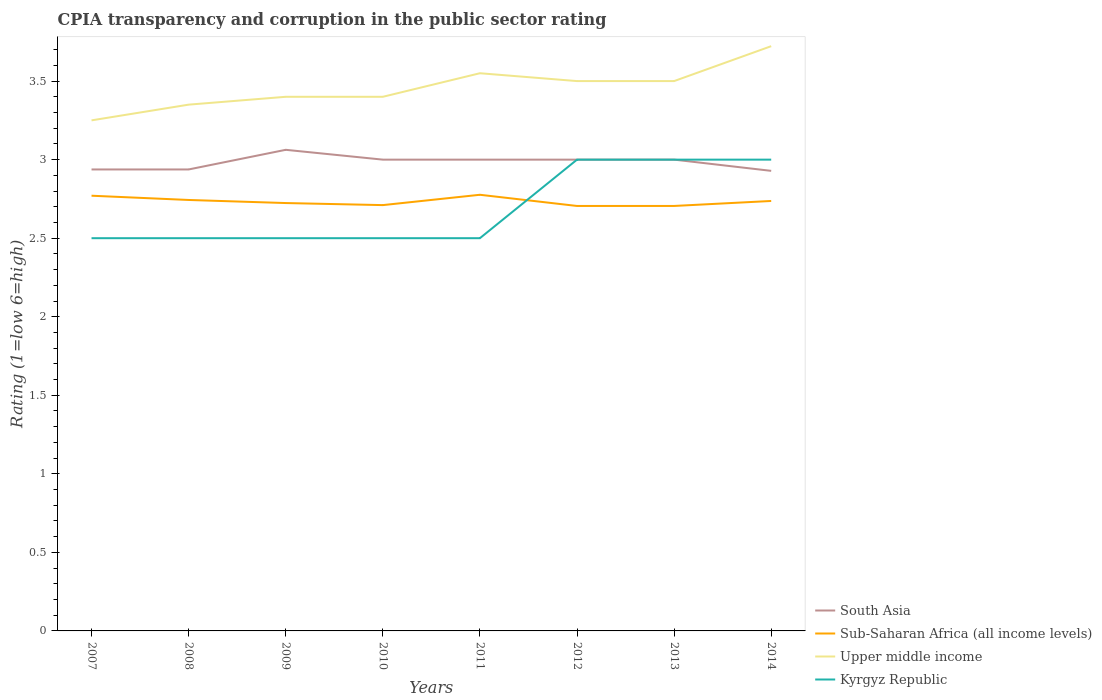Is the number of lines equal to the number of legend labels?
Give a very brief answer. Yes. Across all years, what is the maximum CPIA rating in Sub-Saharan Africa (all income levels)?
Offer a very short reply. 2.71. In which year was the CPIA rating in South Asia maximum?
Make the answer very short. 2014. What is the total CPIA rating in Sub-Saharan Africa (all income levels) in the graph?
Make the answer very short. 0.03. What is the difference between the highest and the second highest CPIA rating in South Asia?
Ensure brevity in your answer.  0.13. What is the difference between the highest and the lowest CPIA rating in Upper middle income?
Give a very brief answer. 4. Is the CPIA rating in Kyrgyz Republic strictly greater than the CPIA rating in Sub-Saharan Africa (all income levels) over the years?
Your response must be concise. No. How many years are there in the graph?
Your answer should be very brief. 8. Are the values on the major ticks of Y-axis written in scientific E-notation?
Keep it short and to the point. No. Does the graph contain grids?
Your answer should be very brief. No. Where does the legend appear in the graph?
Give a very brief answer. Bottom right. How are the legend labels stacked?
Ensure brevity in your answer.  Vertical. What is the title of the graph?
Your answer should be compact. CPIA transparency and corruption in the public sector rating. What is the Rating (1=low 6=high) of South Asia in 2007?
Ensure brevity in your answer.  2.94. What is the Rating (1=low 6=high) of Sub-Saharan Africa (all income levels) in 2007?
Make the answer very short. 2.77. What is the Rating (1=low 6=high) in Kyrgyz Republic in 2007?
Ensure brevity in your answer.  2.5. What is the Rating (1=low 6=high) in South Asia in 2008?
Offer a very short reply. 2.94. What is the Rating (1=low 6=high) in Sub-Saharan Africa (all income levels) in 2008?
Provide a short and direct response. 2.74. What is the Rating (1=low 6=high) in Upper middle income in 2008?
Ensure brevity in your answer.  3.35. What is the Rating (1=low 6=high) in Kyrgyz Republic in 2008?
Offer a very short reply. 2.5. What is the Rating (1=low 6=high) of South Asia in 2009?
Ensure brevity in your answer.  3.06. What is the Rating (1=low 6=high) in Sub-Saharan Africa (all income levels) in 2009?
Offer a very short reply. 2.72. What is the Rating (1=low 6=high) of Upper middle income in 2009?
Your response must be concise. 3.4. What is the Rating (1=low 6=high) in Kyrgyz Republic in 2009?
Ensure brevity in your answer.  2.5. What is the Rating (1=low 6=high) of South Asia in 2010?
Offer a very short reply. 3. What is the Rating (1=low 6=high) in Sub-Saharan Africa (all income levels) in 2010?
Your answer should be very brief. 2.71. What is the Rating (1=low 6=high) of Upper middle income in 2010?
Give a very brief answer. 3.4. What is the Rating (1=low 6=high) in Sub-Saharan Africa (all income levels) in 2011?
Ensure brevity in your answer.  2.78. What is the Rating (1=low 6=high) in Upper middle income in 2011?
Your answer should be compact. 3.55. What is the Rating (1=low 6=high) in South Asia in 2012?
Offer a terse response. 3. What is the Rating (1=low 6=high) in Sub-Saharan Africa (all income levels) in 2012?
Your answer should be very brief. 2.71. What is the Rating (1=low 6=high) of Kyrgyz Republic in 2012?
Offer a terse response. 3. What is the Rating (1=low 6=high) in Sub-Saharan Africa (all income levels) in 2013?
Provide a succinct answer. 2.71. What is the Rating (1=low 6=high) of Upper middle income in 2013?
Offer a terse response. 3.5. What is the Rating (1=low 6=high) of Kyrgyz Republic in 2013?
Provide a short and direct response. 3. What is the Rating (1=low 6=high) in South Asia in 2014?
Offer a terse response. 2.93. What is the Rating (1=low 6=high) in Sub-Saharan Africa (all income levels) in 2014?
Offer a terse response. 2.74. What is the Rating (1=low 6=high) of Upper middle income in 2014?
Your response must be concise. 3.72. Across all years, what is the maximum Rating (1=low 6=high) in South Asia?
Give a very brief answer. 3.06. Across all years, what is the maximum Rating (1=low 6=high) of Sub-Saharan Africa (all income levels)?
Give a very brief answer. 2.78. Across all years, what is the maximum Rating (1=low 6=high) in Upper middle income?
Offer a very short reply. 3.72. Across all years, what is the maximum Rating (1=low 6=high) in Kyrgyz Republic?
Offer a very short reply. 3. Across all years, what is the minimum Rating (1=low 6=high) of South Asia?
Your answer should be very brief. 2.93. Across all years, what is the minimum Rating (1=low 6=high) in Sub-Saharan Africa (all income levels)?
Your answer should be very brief. 2.71. Across all years, what is the minimum Rating (1=low 6=high) in Upper middle income?
Your answer should be compact. 3.25. What is the total Rating (1=low 6=high) of South Asia in the graph?
Give a very brief answer. 23.87. What is the total Rating (1=low 6=high) of Sub-Saharan Africa (all income levels) in the graph?
Your answer should be very brief. 21.87. What is the total Rating (1=low 6=high) of Upper middle income in the graph?
Your response must be concise. 27.67. What is the total Rating (1=low 6=high) of Kyrgyz Republic in the graph?
Give a very brief answer. 21.5. What is the difference between the Rating (1=low 6=high) in South Asia in 2007 and that in 2008?
Make the answer very short. 0. What is the difference between the Rating (1=low 6=high) of Sub-Saharan Africa (all income levels) in 2007 and that in 2008?
Offer a very short reply. 0.03. What is the difference between the Rating (1=low 6=high) in Upper middle income in 2007 and that in 2008?
Provide a succinct answer. -0.1. What is the difference between the Rating (1=low 6=high) of South Asia in 2007 and that in 2009?
Keep it short and to the point. -0.12. What is the difference between the Rating (1=low 6=high) in Sub-Saharan Africa (all income levels) in 2007 and that in 2009?
Ensure brevity in your answer.  0.05. What is the difference between the Rating (1=low 6=high) of Upper middle income in 2007 and that in 2009?
Offer a very short reply. -0.15. What is the difference between the Rating (1=low 6=high) of Kyrgyz Republic in 2007 and that in 2009?
Make the answer very short. 0. What is the difference between the Rating (1=low 6=high) of South Asia in 2007 and that in 2010?
Your answer should be very brief. -0.06. What is the difference between the Rating (1=low 6=high) of Sub-Saharan Africa (all income levels) in 2007 and that in 2010?
Ensure brevity in your answer.  0.06. What is the difference between the Rating (1=low 6=high) of Upper middle income in 2007 and that in 2010?
Make the answer very short. -0.15. What is the difference between the Rating (1=low 6=high) in Kyrgyz Republic in 2007 and that in 2010?
Keep it short and to the point. 0. What is the difference between the Rating (1=low 6=high) in South Asia in 2007 and that in 2011?
Provide a short and direct response. -0.06. What is the difference between the Rating (1=low 6=high) in Sub-Saharan Africa (all income levels) in 2007 and that in 2011?
Your response must be concise. -0.01. What is the difference between the Rating (1=low 6=high) of Kyrgyz Republic in 2007 and that in 2011?
Keep it short and to the point. 0. What is the difference between the Rating (1=low 6=high) in South Asia in 2007 and that in 2012?
Keep it short and to the point. -0.06. What is the difference between the Rating (1=low 6=high) of Sub-Saharan Africa (all income levels) in 2007 and that in 2012?
Give a very brief answer. 0.07. What is the difference between the Rating (1=low 6=high) of Kyrgyz Republic in 2007 and that in 2012?
Provide a short and direct response. -0.5. What is the difference between the Rating (1=low 6=high) of South Asia in 2007 and that in 2013?
Provide a succinct answer. -0.06. What is the difference between the Rating (1=low 6=high) in Sub-Saharan Africa (all income levels) in 2007 and that in 2013?
Offer a terse response. 0.07. What is the difference between the Rating (1=low 6=high) in Kyrgyz Republic in 2007 and that in 2013?
Provide a short and direct response. -0.5. What is the difference between the Rating (1=low 6=high) in South Asia in 2007 and that in 2014?
Provide a succinct answer. 0.01. What is the difference between the Rating (1=low 6=high) in Sub-Saharan Africa (all income levels) in 2007 and that in 2014?
Your answer should be compact. 0.03. What is the difference between the Rating (1=low 6=high) of Upper middle income in 2007 and that in 2014?
Your response must be concise. -0.47. What is the difference between the Rating (1=low 6=high) of South Asia in 2008 and that in 2009?
Your answer should be compact. -0.12. What is the difference between the Rating (1=low 6=high) of Sub-Saharan Africa (all income levels) in 2008 and that in 2009?
Offer a terse response. 0.02. What is the difference between the Rating (1=low 6=high) in Upper middle income in 2008 and that in 2009?
Give a very brief answer. -0.05. What is the difference between the Rating (1=low 6=high) of South Asia in 2008 and that in 2010?
Provide a short and direct response. -0.06. What is the difference between the Rating (1=low 6=high) of Sub-Saharan Africa (all income levels) in 2008 and that in 2010?
Make the answer very short. 0.03. What is the difference between the Rating (1=low 6=high) in Upper middle income in 2008 and that in 2010?
Offer a terse response. -0.05. What is the difference between the Rating (1=low 6=high) in Kyrgyz Republic in 2008 and that in 2010?
Make the answer very short. 0. What is the difference between the Rating (1=low 6=high) of South Asia in 2008 and that in 2011?
Offer a very short reply. -0.06. What is the difference between the Rating (1=low 6=high) in Sub-Saharan Africa (all income levels) in 2008 and that in 2011?
Provide a succinct answer. -0.03. What is the difference between the Rating (1=low 6=high) of South Asia in 2008 and that in 2012?
Offer a very short reply. -0.06. What is the difference between the Rating (1=low 6=high) of Sub-Saharan Africa (all income levels) in 2008 and that in 2012?
Keep it short and to the point. 0.04. What is the difference between the Rating (1=low 6=high) of Upper middle income in 2008 and that in 2012?
Your answer should be very brief. -0.15. What is the difference between the Rating (1=low 6=high) of Kyrgyz Republic in 2008 and that in 2012?
Offer a terse response. -0.5. What is the difference between the Rating (1=low 6=high) in South Asia in 2008 and that in 2013?
Offer a very short reply. -0.06. What is the difference between the Rating (1=low 6=high) in Sub-Saharan Africa (all income levels) in 2008 and that in 2013?
Your response must be concise. 0.04. What is the difference between the Rating (1=low 6=high) of Upper middle income in 2008 and that in 2013?
Provide a short and direct response. -0.15. What is the difference between the Rating (1=low 6=high) in South Asia in 2008 and that in 2014?
Your answer should be very brief. 0.01. What is the difference between the Rating (1=low 6=high) of Sub-Saharan Africa (all income levels) in 2008 and that in 2014?
Offer a terse response. 0.01. What is the difference between the Rating (1=low 6=high) in Upper middle income in 2008 and that in 2014?
Your answer should be very brief. -0.37. What is the difference between the Rating (1=low 6=high) of South Asia in 2009 and that in 2010?
Give a very brief answer. 0.06. What is the difference between the Rating (1=low 6=high) in Sub-Saharan Africa (all income levels) in 2009 and that in 2010?
Make the answer very short. 0.01. What is the difference between the Rating (1=low 6=high) of South Asia in 2009 and that in 2011?
Make the answer very short. 0.06. What is the difference between the Rating (1=low 6=high) of Sub-Saharan Africa (all income levels) in 2009 and that in 2011?
Offer a terse response. -0.05. What is the difference between the Rating (1=low 6=high) of Upper middle income in 2009 and that in 2011?
Provide a short and direct response. -0.15. What is the difference between the Rating (1=low 6=high) of Kyrgyz Republic in 2009 and that in 2011?
Provide a succinct answer. 0. What is the difference between the Rating (1=low 6=high) of South Asia in 2009 and that in 2012?
Provide a succinct answer. 0.06. What is the difference between the Rating (1=low 6=high) of Sub-Saharan Africa (all income levels) in 2009 and that in 2012?
Provide a short and direct response. 0.02. What is the difference between the Rating (1=low 6=high) of Upper middle income in 2009 and that in 2012?
Make the answer very short. -0.1. What is the difference between the Rating (1=low 6=high) of Kyrgyz Republic in 2009 and that in 2012?
Provide a short and direct response. -0.5. What is the difference between the Rating (1=low 6=high) of South Asia in 2009 and that in 2013?
Offer a very short reply. 0.06. What is the difference between the Rating (1=low 6=high) of Sub-Saharan Africa (all income levels) in 2009 and that in 2013?
Make the answer very short. 0.02. What is the difference between the Rating (1=low 6=high) of South Asia in 2009 and that in 2014?
Your answer should be compact. 0.13. What is the difference between the Rating (1=low 6=high) in Sub-Saharan Africa (all income levels) in 2009 and that in 2014?
Your answer should be compact. -0.01. What is the difference between the Rating (1=low 6=high) of Upper middle income in 2009 and that in 2014?
Keep it short and to the point. -0.32. What is the difference between the Rating (1=low 6=high) in Kyrgyz Republic in 2009 and that in 2014?
Keep it short and to the point. -0.5. What is the difference between the Rating (1=low 6=high) of Sub-Saharan Africa (all income levels) in 2010 and that in 2011?
Your answer should be very brief. -0.07. What is the difference between the Rating (1=low 6=high) in Upper middle income in 2010 and that in 2011?
Your answer should be very brief. -0.15. What is the difference between the Rating (1=low 6=high) of Kyrgyz Republic in 2010 and that in 2011?
Provide a succinct answer. 0. What is the difference between the Rating (1=low 6=high) in Sub-Saharan Africa (all income levels) in 2010 and that in 2012?
Your response must be concise. 0.01. What is the difference between the Rating (1=low 6=high) of Kyrgyz Republic in 2010 and that in 2012?
Your answer should be very brief. -0.5. What is the difference between the Rating (1=low 6=high) of South Asia in 2010 and that in 2013?
Your answer should be very brief. 0. What is the difference between the Rating (1=low 6=high) in Sub-Saharan Africa (all income levels) in 2010 and that in 2013?
Your response must be concise. 0.01. What is the difference between the Rating (1=low 6=high) of Upper middle income in 2010 and that in 2013?
Give a very brief answer. -0.1. What is the difference between the Rating (1=low 6=high) of South Asia in 2010 and that in 2014?
Provide a short and direct response. 0.07. What is the difference between the Rating (1=low 6=high) of Sub-Saharan Africa (all income levels) in 2010 and that in 2014?
Offer a very short reply. -0.03. What is the difference between the Rating (1=low 6=high) of Upper middle income in 2010 and that in 2014?
Provide a short and direct response. -0.32. What is the difference between the Rating (1=low 6=high) in Sub-Saharan Africa (all income levels) in 2011 and that in 2012?
Offer a very short reply. 0.07. What is the difference between the Rating (1=low 6=high) of Sub-Saharan Africa (all income levels) in 2011 and that in 2013?
Your response must be concise. 0.07. What is the difference between the Rating (1=low 6=high) of Upper middle income in 2011 and that in 2013?
Your response must be concise. 0.05. What is the difference between the Rating (1=low 6=high) in South Asia in 2011 and that in 2014?
Give a very brief answer. 0.07. What is the difference between the Rating (1=low 6=high) of Sub-Saharan Africa (all income levels) in 2011 and that in 2014?
Provide a succinct answer. 0.04. What is the difference between the Rating (1=low 6=high) of Upper middle income in 2011 and that in 2014?
Make the answer very short. -0.17. What is the difference between the Rating (1=low 6=high) in Sub-Saharan Africa (all income levels) in 2012 and that in 2013?
Offer a terse response. 0. What is the difference between the Rating (1=low 6=high) in Kyrgyz Republic in 2012 and that in 2013?
Give a very brief answer. 0. What is the difference between the Rating (1=low 6=high) of South Asia in 2012 and that in 2014?
Your answer should be very brief. 0.07. What is the difference between the Rating (1=low 6=high) of Sub-Saharan Africa (all income levels) in 2012 and that in 2014?
Keep it short and to the point. -0.03. What is the difference between the Rating (1=low 6=high) in Upper middle income in 2012 and that in 2014?
Provide a short and direct response. -0.22. What is the difference between the Rating (1=low 6=high) of Kyrgyz Republic in 2012 and that in 2014?
Give a very brief answer. 0. What is the difference between the Rating (1=low 6=high) in South Asia in 2013 and that in 2014?
Your response must be concise. 0.07. What is the difference between the Rating (1=low 6=high) of Sub-Saharan Africa (all income levels) in 2013 and that in 2014?
Offer a very short reply. -0.03. What is the difference between the Rating (1=low 6=high) of Upper middle income in 2013 and that in 2014?
Make the answer very short. -0.22. What is the difference between the Rating (1=low 6=high) in Kyrgyz Republic in 2013 and that in 2014?
Ensure brevity in your answer.  0. What is the difference between the Rating (1=low 6=high) of South Asia in 2007 and the Rating (1=low 6=high) of Sub-Saharan Africa (all income levels) in 2008?
Provide a succinct answer. 0.19. What is the difference between the Rating (1=low 6=high) in South Asia in 2007 and the Rating (1=low 6=high) in Upper middle income in 2008?
Provide a succinct answer. -0.41. What is the difference between the Rating (1=low 6=high) in South Asia in 2007 and the Rating (1=low 6=high) in Kyrgyz Republic in 2008?
Your answer should be compact. 0.44. What is the difference between the Rating (1=low 6=high) of Sub-Saharan Africa (all income levels) in 2007 and the Rating (1=low 6=high) of Upper middle income in 2008?
Ensure brevity in your answer.  -0.58. What is the difference between the Rating (1=low 6=high) of Sub-Saharan Africa (all income levels) in 2007 and the Rating (1=low 6=high) of Kyrgyz Republic in 2008?
Your answer should be very brief. 0.27. What is the difference between the Rating (1=low 6=high) in Upper middle income in 2007 and the Rating (1=low 6=high) in Kyrgyz Republic in 2008?
Ensure brevity in your answer.  0.75. What is the difference between the Rating (1=low 6=high) of South Asia in 2007 and the Rating (1=low 6=high) of Sub-Saharan Africa (all income levels) in 2009?
Your answer should be very brief. 0.21. What is the difference between the Rating (1=low 6=high) of South Asia in 2007 and the Rating (1=low 6=high) of Upper middle income in 2009?
Your answer should be compact. -0.46. What is the difference between the Rating (1=low 6=high) of South Asia in 2007 and the Rating (1=low 6=high) of Kyrgyz Republic in 2009?
Your answer should be compact. 0.44. What is the difference between the Rating (1=low 6=high) in Sub-Saharan Africa (all income levels) in 2007 and the Rating (1=low 6=high) in Upper middle income in 2009?
Offer a very short reply. -0.63. What is the difference between the Rating (1=low 6=high) of Sub-Saharan Africa (all income levels) in 2007 and the Rating (1=low 6=high) of Kyrgyz Republic in 2009?
Keep it short and to the point. 0.27. What is the difference between the Rating (1=low 6=high) in Upper middle income in 2007 and the Rating (1=low 6=high) in Kyrgyz Republic in 2009?
Your answer should be compact. 0.75. What is the difference between the Rating (1=low 6=high) in South Asia in 2007 and the Rating (1=low 6=high) in Sub-Saharan Africa (all income levels) in 2010?
Offer a very short reply. 0.23. What is the difference between the Rating (1=low 6=high) of South Asia in 2007 and the Rating (1=low 6=high) of Upper middle income in 2010?
Give a very brief answer. -0.46. What is the difference between the Rating (1=low 6=high) of South Asia in 2007 and the Rating (1=low 6=high) of Kyrgyz Republic in 2010?
Provide a succinct answer. 0.44. What is the difference between the Rating (1=low 6=high) of Sub-Saharan Africa (all income levels) in 2007 and the Rating (1=low 6=high) of Upper middle income in 2010?
Make the answer very short. -0.63. What is the difference between the Rating (1=low 6=high) in Sub-Saharan Africa (all income levels) in 2007 and the Rating (1=low 6=high) in Kyrgyz Republic in 2010?
Offer a terse response. 0.27. What is the difference between the Rating (1=low 6=high) of Upper middle income in 2007 and the Rating (1=low 6=high) of Kyrgyz Republic in 2010?
Make the answer very short. 0.75. What is the difference between the Rating (1=low 6=high) in South Asia in 2007 and the Rating (1=low 6=high) in Sub-Saharan Africa (all income levels) in 2011?
Give a very brief answer. 0.16. What is the difference between the Rating (1=low 6=high) in South Asia in 2007 and the Rating (1=low 6=high) in Upper middle income in 2011?
Make the answer very short. -0.61. What is the difference between the Rating (1=low 6=high) in South Asia in 2007 and the Rating (1=low 6=high) in Kyrgyz Republic in 2011?
Ensure brevity in your answer.  0.44. What is the difference between the Rating (1=low 6=high) of Sub-Saharan Africa (all income levels) in 2007 and the Rating (1=low 6=high) of Upper middle income in 2011?
Ensure brevity in your answer.  -0.78. What is the difference between the Rating (1=low 6=high) in Sub-Saharan Africa (all income levels) in 2007 and the Rating (1=low 6=high) in Kyrgyz Republic in 2011?
Provide a short and direct response. 0.27. What is the difference between the Rating (1=low 6=high) in Upper middle income in 2007 and the Rating (1=low 6=high) in Kyrgyz Republic in 2011?
Your answer should be very brief. 0.75. What is the difference between the Rating (1=low 6=high) of South Asia in 2007 and the Rating (1=low 6=high) of Sub-Saharan Africa (all income levels) in 2012?
Your answer should be very brief. 0.23. What is the difference between the Rating (1=low 6=high) in South Asia in 2007 and the Rating (1=low 6=high) in Upper middle income in 2012?
Keep it short and to the point. -0.56. What is the difference between the Rating (1=low 6=high) of South Asia in 2007 and the Rating (1=low 6=high) of Kyrgyz Republic in 2012?
Ensure brevity in your answer.  -0.06. What is the difference between the Rating (1=low 6=high) in Sub-Saharan Africa (all income levels) in 2007 and the Rating (1=low 6=high) in Upper middle income in 2012?
Keep it short and to the point. -0.73. What is the difference between the Rating (1=low 6=high) of Sub-Saharan Africa (all income levels) in 2007 and the Rating (1=low 6=high) of Kyrgyz Republic in 2012?
Your answer should be compact. -0.23. What is the difference between the Rating (1=low 6=high) in South Asia in 2007 and the Rating (1=low 6=high) in Sub-Saharan Africa (all income levels) in 2013?
Keep it short and to the point. 0.23. What is the difference between the Rating (1=low 6=high) of South Asia in 2007 and the Rating (1=low 6=high) of Upper middle income in 2013?
Provide a short and direct response. -0.56. What is the difference between the Rating (1=low 6=high) of South Asia in 2007 and the Rating (1=low 6=high) of Kyrgyz Republic in 2013?
Offer a terse response. -0.06. What is the difference between the Rating (1=low 6=high) of Sub-Saharan Africa (all income levels) in 2007 and the Rating (1=low 6=high) of Upper middle income in 2013?
Provide a short and direct response. -0.73. What is the difference between the Rating (1=low 6=high) in Sub-Saharan Africa (all income levels) in 2007 and the Rating (1=low 6=high) in Kyrgyz Republic in 2013?
Give a very brief answer. -0.23. What is the difference between the Rating (1=low 6=high) in South Asia in 2007 and the Rating (1=low 6=high) in Sub-Saharan Africa (all income levels) in 2014?
Offer a very short reply. 0.2. What is the difference between the Rating (1=low 6=high) in South Asia in 2007 and the Rating (1=low 6=high) in Upper middle income in 2014?
Ensure brevity in your answer.  -0.78. What is the difference between the Rating (1=low 6=high) of South Asia in 2007 and the Rating (1=low 6=high) of Kyrgyz Republic in 2014?
Give a very brief answer. -0.06. What is the difference between the Rating (1=low 6=high) in Sub-Saharan Africa (all income levels) in 2007 and the Rating (1=low 6=high) in Upper middle income in 2014?
Offer a terse response. -0.95. What is the difference between the Rating (1=low 6=high) in Sub-Saharan Africa (all income levels) in 2007 and the Rating (1=low 6=high) in Kyrgyz Republic in 2014?
Your response must be concise. -0.23. What is the difference between the Rating (1=low 6=high) in South Asia in 2008 and the Rating (1=low 6=high) in Sub-Saharan Africa (all income levels) in 2009?
Your answer should be compact. 0.21. What is the difference between the Rating (1=low 6=high) of South Asia in 2008 and the Rating (1=low 6=high) of Upper middle income in 2009?
Your answer should be compact. -0.46. What is the difference between the Rating (1=low 6=high) of South Asia in 2008 and the Rating (1=low 6=high) of Kyrgyz Republic in 2009?
Keep it short and to the point. 0.44. What is the difference between the Rating (1=low 6=high) of Sub-Saharan Africa (all income levels) in 2008 and the Rating (1=low 6=high) of Upper middle income in 2009?
Your answer should be very brief. -0.66. What is the difference between the Rating (1=low 6=high) in Sub-Saharan Africa (all income levels) in 2008 and the Rating (1=low 6=high) in Kyrgyz Republic in 2009?
Give a very brief answer. 0.24. What is the difference between the Rating (1=low 6=high) in South Asia in 2008 and the Rating (1=low 6=high) in Sub-Saharan Africa (all income levels) in 2010?
Provide a succinct answer. 0.23. What is the difference between the Rating (1=low 6=high) in South Asia in 2008 and the Rating (1=low 6=high) in Upper middle income in 2010?
Your answer should be very brief. -0.46. What is the difference between the Rating (1=low 6=high) of South Asia in 2008 and the Rating (1=low 6=high) of Kyrgyz Republic in 2010?
Provide a short and direct response. 0.44. What is the difference between the Rating (1=low 6=high) in Sub-Saharan Africa (all income levels) in 2008 and the Rating (1=low 6=high) in Upper middle income in 2010?
Your answer should be compact. -0.66. What is the difference between the Rating (1=low 6=high) of Sub-Saharan Africa (all income levels) in 2008 and the Rating (1=low 6=high) of Kyrgyz Republic in 2010?
Make the answer very short. 0.24. What is the difference between the Rating (1=low 6=high) in Upper middle income in 2008 and the Rating (1=low 6=high) in Kyrgyz Republic in 2010?
Keep it short and to the point. 0.85. What is the difference between the Rating (1=low 6=high) in South Asia in 2008 and the Rating (1=low 6=high) in Sub-Saharan Africa (all income levels) in 2011?
Provide a short and direct response. 0.16. What is the difference between the Rating (1=low 6=high) in South Asia in 2008 and the Rating (1=low 6=high) in Upper middle income in 2011?
Keep it short and to the point. -0.61. What is the difference between the Rating (1=low 6=high) in South Asia in 2008 and the Rating (1=low 6=high) in Kyrgyz Republic in 2011?
Your answer should be very brief. 0.44. What is the difference between the Rating (1=low 6=high) in Sub-Saharan Africa (all income levels) in 2008 and the Rating (1=low 6=high) in Upper middle income in 2011?
Your answer should be compact. -0.81. What is the difference between the Rating (1=low 6=high) of Sub-Saharan Africa (all income levels) in 2008 and the Rating (1=low 6=high) of Kyrgyz Republic in 2011?
Give a very brief answer. 0.24. What is the difference between the Rating (1=low 6=high) of South Asia in 2008 and the Rating (1=low 6=high) of Sub-Saharan Africa (all income levels) in 2012?
Make the answer very short. 0.23. What is the difference between the Rating (1=low 6=high) of South Asia in 2008 and the Rating (1=low 6=high) of Upper middle income in 2012?
Your answer should be compact. -0.56. What is the difference between the Rating (1=low 6=high) of South Asia in 2008 and the Rating (1=low 6=high) of Kyrgyz Republic in 2012?
Your response must be concise. -0.06. What is the difference between the Rating (1=low 6=high) in Sub-Saharan Africa (all income levels) in 2008 and the Rating (1=low 6=high) in Upper middle income in 2012?
Offer a terse response. -0.76. What is the difference between the Rating (1=low 6=high) of Sub-Saharan Africa (all income levels) in 2008 and the Rating (1=low 6=high) of Kyrgyz Republic in 2012?
Ensure brevity in your answer.  -0.26. What is the difference between the Rating (1=low 6=high) in Upper middle income in 2008 and the Rating (1=low 6=high) in Kyrgyz Republic in 2012?
Your answer should be compact. 0.35. What is the difference between the Rating (1=low 6=high) in South Asia in 2008 and the Rating (1=low 6=high) in Sub-Saharan Africa (all income levels) in 2013?
Give a very brief answer. 0.23. What is the difference between the Rating (1=low 6=high) of South Asia in 2008 and the Rating (1=low 6=high) of Upper middle income in 2013?
Give a very brief answer. -0.56. What is the difference between the Rating (1=low 6=high) in South Asia in 2008 and the Rating (1=low 6=high) in Kyrgyz Republic in 2013?
Provide a succinct answer. -0.06. What is the difference between the Rating (1=low 6=high) of Sub-Saharan Africa (all income levels) in 2008 and the Rating (1=low 6=high) of Upper middle income in 2013?
Keep it short and to the point. -0.76. What is the difference between the Rating (1=low 6=high) of Sub-Saharan Africa (all income levels) in 2008 and the Rating (1=low 6=high) of Kyrgyz Republic in 2013?
Keep it short and to the point. -0.26. What is the difference between the Rating (1=low 6=high) in South Asia in 2008 and the Rating (1=low 6=high) in Sub-Saharan Africa (all income levels) in 2014?
Provide a succinct answer. 0.2. What is the difference between the Rating (1=low 6=high) of South Asia in 2008 and the Rating (1=low 6=high) of Upper middle income in 2014?
Give a very brief answer. -0.78. What is the difference between the Rating (1=low 6=high) in South Asia in 2008 and the Rating (1=low 6=high) in Kyrgyz Republic in 2014?
Your answer should be very brief. -0.06. What is the difference between the Rating (1=low 6=high) of Sub-Saharan Africa (all income levels) in 2008 and the Rating (1=low 6=high) of Upper middle income in 2014?
Offer a terse response. -0.98. What is the difference between the Rating (1=low 6=high) of Sub-Saharan Africa (all income levels) in 2008 and the Rating (1=low 6=high) of Kyrgyz Republic in 2014?
Provide a succinct answer. -0.26. What is the difference between the Rating (1=low 6=high) in South Asia in 2009 and the Rating (1=low 6=high) in Sub-Saharan Africa (all income levels) in 2010?
Your answer should be compact. 0.35. What is the difference between the Rating (1=low 6=high) in South Asia in 2009 and the Rating (1=low 6=high) in Upper middle income in 2010?
Your response must be concise. -0.34. What is the difference between the Rating (1=low 6=high) in South Asia in 2009 and the Rating (1=low 6=high) in Kyrgyz Republic in 2010?
Give a very brief answer. 0.56. What is the difference between the Rating (1=low 6=high) in Sub-Saharan Africa (all income levels) in 2009 and the Rating (1=low 6=high) in Upper middle income in 2010?
Keep it short and to the point. -0.68. What is the difference between the Rating (1=low 6=high) of Sub-Saharan Africa (all income levels) in 2009 and the Rating (1=low 6=high) of Kyrgyz Republic in 2010?
Give a very brief answer. 0.22. What is the difference between the Rating (1=low 6=high) of South Asia in 2009 and the Rating (1=low 6=high) of Sub-Saharan Africa (all income levels) in 2011?
Provide a short and direct response. 0.29. What is the difference between the Rating (1=low 6=high) of South Asia in 2009 and the Rating (1=low 6=high) of Upper middle income in 2011?
Make the answer very short. -0.49. What is the difference between the Rating (1=low 6=high) in South Asia in 2009 and the Rating (1=low 6=high) in Kyrgyz Republic in 2011?
Provide a succinct answer. 0.56. What is the difference between the Rating (1=low 6=high) in Sub-Saharan Africa (all income levels) in 2009 and the Rating (1=low 6=high) in Upper middle income in 2011?
Provide a succinct answer. -0.83. What is the difference between the Rating (1=low 6=high) in Sub-Saharan Africa (all income levels) in 2009 and the Rating (1=low 6=high) in Kyrgyz Republic in 2011?
Offer a very short reply. 0.22. What is the difference between the Rating (1=low 6=high) of South Asia in 2009 and the Rating (1=low 6=high) of Sub-Saharan Africa (all income levels) in 2012?
Keep it short and to the point. 0.36. What is the difference between the Rating (1=low 6=high) in South Asia in 2009 and the Rating (1=low 6=high) in Upper middle income in 2012?
Your answer should be compact. -0.44. What is the difference between the Rating (1=low 6=high) in South Asia in 2009 and the Rating (1=low 6=high) in Kyrgyz Republic in 2012?
Give a very brief answer. 0.06. What is the difference between the Rating (1=low 6=high) in Sub-Saharan Africa (all income levels) in 2009 and the Rating (1=low 6=high) in Upper middle income in 2012?
Your answer should be compact. -0.78. What is the difference between the Rating (1=low 6=high) of Sub-Saharan Africa (all income levels) in 2009 and the Rating (1=low 6=high) of Kyrgyz Republic in 2012?
Provide a short and direct response. -0.28. What is the difference between the Rating (1=low 6=high) of Upper middle income in 2009 and the Rating (1=low 6=high) of Kyrgyz Republic in 2012?
Your answer should be very brief. 0.4. What is the difference between the Rating (1=low 6=high) in South Asia in 2009 and the Rating (1=low 6=high) in Sub-Saharan Africa (all income levels) in 2013?
Offer a very short reply. 0.36. What is the difference between the Rating (1=low 6=high) of South Asia in 2009 and the Rating (1=low 6=high) of Upper middle income in 2013?
Ensure brevity in your answer.  -0.44. What is the difference between the Rating (1=low 6=high) in South Asia in 2009 and the Rating (1=low 6=high) in Kyrgyz Republic in 2013?
Offer a terse response. 0.06. What is the difference between the Rating (1=low 6=high) of Sub-Saharan Africa (all income levels) in 2009 and the Rating (1=low 6=high) of Upper middle income in 2013?
Offer a terse response. -0.78. What is the difference between the Rating (1=low 6=high) of Sub-Saharan Africa (all income levels) in 2009 and the Rating (1=low 6=high) of Kyrgyz Republic in 2013?
Keep it short and to the point. -0.28. What is the difference between the Rating (1=low 6=high) of Upper middle income in 2009 and the Rating (1=low 6=high) of Kyrgyz Republic in 2013?
Offer a very short reply. 0.4. What is the difference between the Rating (1=low 6=high) in South Asia in 2009 and the Rating (1=low 6=high) in Sub-Saharan Africa (all income levels) in 2014?
Your answer should be compact. 0.33. What is the difference between the Rating (1=low 6=high) of South Asia in 2009 and the Rating (1=low 6=high) of Upper middle income in 2014?
Keep it short and to the point. -0.66. What is the difference between the Rating (1=low 6=high) of South Asia in 2009 and the Rating (1=low 6=high) of Kyrgyz Republic in 2014?
Your answer should be very brief. 0.06. What is the difference between the Rating (1=low 6=high) in Sub-Saharan Africa (all income levels) in 2009 and the Rating (1=low 6=high) in Upper middle income in 2014?
Offer a very short reply. -1. What is the difference between the Rating (1=low 6=high) in Sub-Saharan Africa (all income levels) in 2009 and the Rating (1=low 6=high) in Kyrgyz Republic in 2014?
Offer a very short reply. -0.28. What is the difference between the Rating (1=low 6=high) of South Asia in 2010 and the Rating (1=low 6=high) of Sub-Saharan Africa (all income levels) in 2011?
Keep it short and to the point. 0.22. What is the difference between the Rating (1=low 6=high) in South Asia in 2010 and the Rating (1=low 6=high) in Upper middle income in 2011?
Your response must be concise. -0.55. What is the difference between the Rating (1=low 6=high) in Sub-Saharan Africa (all income levels) in 2010 and the Rating (1=low 6=high) in Upper middle income in 2011?
Give a very brief answer. -0.84. What is the difference between the Rating (1=low 6=high) of Sub-Saharan Africa (all income levels) in 2010 and the Rating (1=low 6=high) of Kyrgyz Republic in 2011?
Your answer should be compact. 0.21. What is the difference between the Rating (1=low 6=high) of South Asia in 2010 and the Rating (1=low 6=high) of Sub-Saharan Africa (all income levels) in 2012?
Offer a terse response. 0.29. What is the difference between the Rating (1=low 6=high) in Sub-Saharan Africa (all income levels) in 2010 and the Rating (1=low 6=high) in Upper middle income in 2012?
Your response must be concise. -0.79. What is the difference between the Rating (1=low 6=high) of Sub-Saharan Africa (all income levels) in 2010 and the Rating (1=low 6=high) of Kyrgyz Republic in 2012?
Provide a succinct answer. -0.29. What is the difference between the Rating (1=low 6=high) of South Asia in 2010 and the Rating (1=low 6=high) of Sub-Saharan Africa (all income levels) in 2013?
Give a very brief answer. 0.29. What is the difference between the Rating (1=low 6=high) in South Asia in 2010 and the Rating (1=low 6=high) in Upper middle income in 2013?
Give a very brief answer. -0.5. What is the difference between the Rating (1=low 6=high) in South Asia in 2010 and the Rating (1=low 6=high) in Kyrgyz Republic in 2013?
Give a very brief answer. 0. What is the difference between the Rating (1=low 6=high) of Sub-Saharan Africa (all income levels) in 2010 and the Rating (1=low 6=high) of Upper middle income in 2013?
Give a very brief answer. -0.79. What is the difference between the Rating (1=low 6=high) in Sub-Saharan Africa (all income levels) in 2010 and the Rating (1=low 6=high) in Kyrgyz Republic in 2013?
Provide a succinct answer. -0.29. What is the difference between the Rating (1=low 6=high) in South Asia in 2010 and the Rating (1=low 6=high) in Sub-Saharan Africa (all income levels) in 2014?
Make the answer very short. 0.26. What is the difference between the Rating (1=low 6=high) in South Asia in 2010 and the Rating (1=low 6=high) in Upper middle income in 2014?
Offer a terse response. -0.72. What is the difference between the Rating (1=low 6=high) in Sub-Saharan Africa (all income levels) in 2010 and the Rating (1=low 6=high) in Upper middle income in 2014?
Your response must be concise. -1.01. What is the difference between the Rating (1=low 6=high) of Sub-Saharan Africa (all income levels) in 2010 and the Rating (1=low 6=high) of Kyrgyz Republic in 2014?
Keep it short and to the point. -0.29. What is the difference between the Rating (1=low 6=high) in South Asia in 2011 and the Rating (1=low 6=high) in Sub-Saharan Africa (all income levels) in 2012?
Ensure brevity in your answer.  0.29. What is the difference between the Rating (1=low 6=high) of South Asia in 2011 and the Rating (1=low 6=high) of Kyrgyz Republic in 2012?
Provide a succinct answer. 0. What is the difference between the Rating (1=low 6=high) in Sub-Saharan Africa (all income levels) in 2011 and the Rating (1=low 6=high) in Upper middle income in 2012?
Ensure brevity in your answer.  -0.72. What is the difference between the Rating (1=low 6=high) in Sub-Saharan Africa (all income levels) in 2011 and the Rating (1=low 6=high) in Kyrgyz Republic in 2012?
Give a very brief answer. -0.22. What is the difference between the Rating (1=low 6=high) of Upper middle income in 2011 and the Rating (1=low 6=high) of Kyrgyz Republic in 2012?
Ensure brevity in your answer.  0.55. What is the difference between the Rating (1=low 6=high) in South Asia in 2011 and the Rating (1=low 6=high) in Sub-Saharan Africa (all income levels) in 2013?
Your answer should be compact. 0.29. What is the difference between the Rating (1=low 6=high) of South Asia in 2011 and the Rating (1=low 6=high) of Upper middle income in 2013?
Make the answer very short. -0.5. What is the difference between the Rating (1=low 6=high) of South Asia in 2011 and the Rating (1=low 6=high) of Kyrgyz Republic in 2013?
Offer a very short reply. 0. What is the difference between the Rating (1=low 6=high) of Sub-Saharan Africa (all income levels) in 2011 and the Rating (1=low 6=high) of Upper middle income in 2013?
Give a very brief answer. -0.72. What is the difference between the Rating (1=low 6=high) of Sub-Saharan Africa (all income levels) in 2011 and the Rating (1=low 6=high) of Kyrgyz Republic in 2013?
Make the answer very short. -0.22. What is the difference between the Rating (1=low 6=high) in Upper middle income in 2011 and the Rating (1=low 6=high) in Kyrgyz Republic in 2013?
Provide a succinct answer. 0.55. What is the difference between the Rating (1=low 6=high) in South Asia in 2011 and the Rating (1=low 6=high) in Sub-Saharan Africa (all income levels) in 2014?
Provide a succinct answer. 0.26. What is the difference between the Rating (1=low 6=high) of South Asia in 2011 and the Rating (1=low 6=high) of Upper middle income in 2014?
Your answer should be compact. -0.72. What is the difference between the Rating (1=low 6=high) of Sub-Saharan Africa (all income levels) in 2011 and the Rating (1=low 6=high) of Upper middle income in 2014?
Provide a succinct answer. -0.95. What is the difference between the Rating (1=low 6=high) of Sub-Saharan Africa (all income levels) in 2011 and the Rating (1=low 6=high) of Kyrgyz Republic in 2014?
Provide a short and direct response. -0.22. What is the difference between the Rating (1=low 6=high) in Upper middle income in 2011 and the Rating (1=low 6=high) in Kyrgyz Republic in 2014?
Keep it short and to the point. 0.55. What is the difference between the Rating (1=low 6=high) in South Asia in 2012 and the Rating (1=low 6=high) in Sub-Saharan Africa (all income levels) in 2013?
Offer a very short reply. 0.29. What is the difference between the Rating (1=low 6=high) in Sub-Saharan Africa (all income levels) in 2012 and the Rating (1=low 6=high) in Upper middle income in 2013?
Make the answer very short. -0.79. What is the difference between the Rating (1=low 6=high) in Sub-Saharan Africa (all income levels) in 2012 and the Rating (1=low 6=high) in Kyrgyz Republic in 2013?
Provide a succinct answer. -0.29. What is the difference between the Rating (1=low 6=high) of South Asia in 2012 and the Rating (1=low 6=high) of Sub-Saharan Africa (all income levels) in 2014?
Offer a terse response. 0.26. What is the difference between the Rating (1=low 6=high) of South Asia in 2012 and the Rating (1=low 6=high) of Upper middle income in 2014?
Ensure brevity in your answer.  -0.72. What is the difference between the Rating (1=low 6=high) in Sub-Saharan Africa (all income levels) in 2012 and the Rating (1=low 6=high) in Upper middle income in 2014?
Provide a succinct answer. -1.02. What is the difference between the Rating (1=low 6=high) in Sub-Saharan Africa (all income levels) in 2012 and the Rating (1=low 6=high) in Kyrgyz Republic in 2014?
Your response must be concise. -0.29. What is the difference between the Rating (1=low 6=high) in South Asia in 2013 and the Rating (1=low 6=high) in Sub-Saharan Africa (all income levels) in 2014?
Provide a succinct answer. 0.26. What is the difference between the Rating (1=low 6=high) in South Asia in 2013 and the Rating (1=low 6=high) in Upper middle income in 2014?
Give a very brief answer. -0.72. What is the difference between the Rating (1=low 6=high) of South Asia in 2013 and the Rating (1=low 6=high) of Kyrgyz Republic in 2014?
Your response must be concise. 0. What is the difference between the Rating (1=low 6=high) of Sub-Saharan Africa (all income levels) in 2013 and the Rating (1=low 6=high) of Upper middle income in 2014?
Your answer should be compact. -1.02. What is the difference between the Rating (1=low 6=high) in Sub-Saharan Africa (all income levels) in 2013 and the Rating (1=low 6=high) in Kyrgyz Republic in 2014?
Ensure brevity in your answer.  -0.29. What is the average Rating (1=low 6=high) in South Asia per year?
Provide a succinct answer. 2.98. What is the average Rating (1=low 6=high) of Sub-Saharan Africa (all income levels) per year?
Keep it short and to the point. 2.73. What is the average Rating (1=low 6=high) of Upper middle income per year?
Your response must be concise. 3.46. What is the average Rating (1=low 6=high) in Kyrgyz Republic per year?
Keep it short and to the point. 2.69. In the year 2007, what is the difference between the Rating (1=low 6=high) in South Asia and Rating (1=low 6=high) in Sub-Saharan Africa (all income levels)?
Offer a terse response. 0.17. In the year 2007, what is the difference between the Rating (1=low 6=high) of South Asia and Rating (1=low 6=high) of Upper middle income?
Offer a terse response. -0.31. In the year 2007, what is the difference between the Rating (1=low 6=high) of South Asia and Rating (1=low 6=high) of Kyrgyz Republic?
Offer a terse response. 0.44. In the year 2007, what is the difference between the Rating (1=low 6=high) in Sub-Saharan Africa (all income levels) and Rating (1=low 6=high) in Upper middle income?
Give a very brief answer. -0.48. In the year 2007, what is the difference between the Rating (1=low 6=high) in Sub-Saharan Africa (all income levels) and Rating (1=low 6=high) in Kyrgyz Republic?
Keep it short and to the point. 0.27. In the year 2007, what is the difference between the Rating (1=low 6=high) of Upper middle income and Rating (1=low 6=high) of Kyrgyz Republic?
Make the answer very short. 0.75. In the year 2008, what is the difference between the Rating (1=low 6=high) in South Asia and Rating (1=low 6=high) in Sub-Saharan Africa (all income levels)?
Offer a very short reply. 0.19. In the year 2008, what is the difference between the Rating (1=low 6=high) in South Asia and Rating (1=low 6=high) in Upper middle income?
Your answer should be very brief. -0.41. In the year 2008, what is the difference between the Rating (1=low 6=high) of South Asia and Rating (1=low 6=high) of Kyrgyz Republic?
Keep it short and to the point. 0.44. In the year 2008, what is the difference between the Rating (1=low 6=high) of Sub-Saharan Africa (all income levels) and Rating (1=low 6=high) of Upper middle income?
Keep it short and to the point. -0.61. In the year 2008, what is the difference between the Rating (1=low 6=high) of Sub-Saharan Africa (all income levels) and Rating (1=low 6=high) of Kyrgyz Republic?
Keep it short and to the point. 0.24. In the year 2008, what is the difference between the Rating (1=low 6=high) of Upper middle income and Rating (1=low 6=high) of Kyrgyz Republic?
Give a very brief answer. 0.85. In the year 2009, what is the difference between the Rating (1=low 6=high) of South Asia and Rating (1=low 6=high) of Sub-Saharan Africa (all income levels)?
Make the answer very short. 0.34. In the year 2009, what is the difference between the Rating (1=low 6=high) of South Asia and Rating (1=low 6=high) of Upper middle income?
Offer a terse response. -0.34. In the year 2009, what is the difference between the Rating (1=low 6=high) of South Asia and Rating (1=low 6=high) of Kyrgyz Republic?
Your response must be concise. 0.56. In the year 2009, what is the difference between the Rating (1=low 6=high) of Sub-Saharan Africa (all income levels) and Rating (1=low 6=high) of Upper middle income?
Your response must be concise. -0.68. In the year 2009, what is the difference between the Rating (1=low 6=high) in Sub-Saharan Africa (all income levels) and Rating (1=low 6=high) in Kyrgyz Republic?
Offer a very short reply. 0.22. In the year 2010, what is the difference between the Rating (1=low 6=high) of South Asia and Rating (1=low 6=high) of Sub-Saharan Africa (all income levels)?
Make the answer very short. 0.29. In the year 2010, what is the difference between the Rating (1=low 6=high) of South Asia and Rating (1=low 6=high) of Kyrgyz Republic?
Your response must be concise. 0.5. In the year 2010, what is the difference between the Rating (1=low 6=high) of Sub-Saharan Africa (all income levels) and Rating (1=low 6=high) of Upper middle income?
Offer a terse response. -0.69. In the year 2010, what is the difference between the Rating (1=low 6=high) in Sub-Saharan Africa (all income levels) and Rating (1=low 6=high) in Kyrgyz Republic?
Keep it short and to the point. 0.21. In the year 2011, what is the difference between the Rating (1=low 6=high) of South Asia and Rating (1=low 6=high) of Sub-Saharan Africa (all income levels)?
Your answer should be very brief. 0.22. In the year 2011, what is the difference between the Rating (1=low 6=high) in South Asia and Rating (1=low 6=high) in Upper middle income?
Provide a short and direct response. -0.55. In the year 2011, what is the difference between the Rating (1=low 6=high) in Sub-Saharan Africa (all income levels) and Rating (1=low 6=high) in Upper middle income?
Ensure brevity in your answer.  -0.77. In the year 2011, what is the difference between the Rating (1=low 6=high) of Sub-Saharan Africa (all income levels) and Rating (1=low 6=high) of Kyrgyz Republic?
Provide a short and direct response. 0.28. In the year 2012, what is the difference between the Rating (1=low 6=high) in South Asia and Rating (1=low 6=high) in Sub-Saharan Africa (all income levels)?
Your response must be concise. 0.29. In the year 2012, what is the difference between the Rating (1=low 6=high) in Sub-Saharan Africa (all income levels) and Rating (1=low 6=high) in Upper middle income?
Keep it short and to the point. -0.79. In the year 2012, what is the difference between the Rating (1=low 6=high) of Sub-Saharan Africa (all income levels) and Rating (1=low 6=high) of Kyrgyz Republic?
Provide a short and direct response. -0.29. In the year 2013, what is the difference between the Rating (1=low 6=high) in South Asia and Rating (1=low 6=high) in Sub-Saharan Africa (all income levels)?
Your answer should be compact. 0.29. In the year 2013, what is the difference between the Rating (1=low 6=high) in South Asia and Rating (1=low 6=high) in Upper middle income?
Keep it short and to the point. -0.5. In the year 2013, what is the difference between the Rating (1=low 6=high) of Sub-Saharan Africa (all income levels) and Rating (1=low 6=high) of Upper middle income?
Keep it short and to the point. -0.79. In the year 2013, what is the difference between the Rating (1=low 6=high) of Sub-Saharan Africa (all income levels) and Rating (1=low 6=high) of Kyrgyz Republic?
Your answer should be very brief. -0.29. In the year 2014, what is the difference between the Rating (1=low 6=high) of South Asia and Rating (1=low 6=high) of Sub-Saharan Africa (all income levels)?
Ensure brevity in your answer.  0.19. In the year 2014, what is the difference between the Rating (1=low 6=high) in South Asia and Rating (1=low 6=high) in Upper middle income?
Offer a terse response. -0.79. In the year 2014, what is the difference between the Rating (1=low 6=high) in South Asia and Rating (1=low 6=high) in Kyrgyz Republic?
Your answer should be compact. -0.07. In the year 2014, what is the difference between the Rating (1=low 6=high) in Sub-Saharan Africa (all income levels) and Rating (1=low 6=high) in Upper middle income?
Offer a very short reply. -0.99. In the year 2014, what is the difference between the Rating (1=low 6=high) in Sub-Saharan Africa (all income levels) and Rating (1=low 6=high) in Kyrgyz Republic?
Make the answer very short. -0.26. In the year 2014, what is the difference between the Rating (1=low 6=high) of Upper middle income and Rating (1=low 6=high) of Kyrgyz Republic?
Keep it short and to the point. 0.72. What is the ratio of the Rating (1=low 6=high) in Sub-Saharan Africa (all income levels) in 2007 to that in 2008?
Give a very brief answer. 1.01. What is the ratio of the Rating (1=low 6=high) of Upper middle income in 2007 to that in 2008?
Give a very brief answer. 0.97. What is the ratio of the Rating (1=low 6=high) in South Asia in 2007 to that in 2009?
Your response must be concise. 0.96. What is the ratio of the Rating (1=low 6=high) of Sub-Saharan Africa (all income levels) in 2007 to that in 2009?
Provide a short and direct response. 1.02. What is the ratio of the Rating (1=low 6=high) in Upper middle income in 2007 to that in 2009?
Give a very brief answer. 0.96. What is the ratio of the Rating (1=low 6=high) of South Asia in 2007 to that in 2010?
Provide a succinct answer. 0.98. What is the ratio of the Rating (1=low 6=high) of Sub-Saharan Africa (all income levels) in 2007 to that in 2010?
Your response must be concise. 1.02. What is the ratio of the Rating (1=low 6=high) in Upper middle income in 2007 to that in 2010?
Provide a short and direct response. 0.96. What is the ratio of the Rating (1=low 6=high) of South Asia in 2007 to that in 2011?
Keep it short and to the point. 0.98. What is the ratio of the Rating (1=low 6=high) in Upper middle income in 2007 to that in 2011?
Provide a short and direct response. 0.92. What is the ratio of the Rating (1=low 6=high) in South Asia in 2007 to that in 2012?
Keep it short and to the point. 0.98. What is the ratio of the Rating (1=low 6=high) of Sub-Saharan Africa (all income levels) in 2007 to that in 2012?
Give a very brief answer. 1.02. What is the ratio of the Rating (1=low 6=high) of Upper middle income in 2007 to that in 2012?
Make the answer very short. 0.93. What is the ratio of the Rating (1=low 6=high) in Kyrgyz Republic in 2007 to that in 2012?
Give a very brief answer. 0.83. What is the ratio of the Rating (1=low 6=high) of South Asia in 2007 to that in 2013?
Make the answer very short. 0.98. What is the ratio of the Rating (1=low 6=high) of Sub-Saharan Africa (all income levels) in 2007 to that in 2013?
Give a very brief answer. 1.02. What is the ratio of the Rating (1=low 6=high) in South Asia in 2007 to that in 2014?
Make the answer very short. 1. What is the ratio of the Rating (1=low 6=high) of Sub-Saharan Africa (all income levels) in 2007 to that in 2014?
Keep it short and to the point. 1.01. What is the ratio of the Rating (1=low 6=high) in Upper middle income in 2007 to that in 2014?
Keep it short and to the point. 0.87. What is the ratio of the Rating (1=low 6=high) in Kyrgyz Republic in 2007 to that in 2014?
Ensure brevity in your answer.  0.83. What is the ratio of the Rating (1=low 6=high) of South Asia in 2008 to that in 2009?
Offer a terse response. 0.96. What is the ratio of the Rating (1=low 6=high) of South Asia in 2008 to that in 2010?
Offer a terse response. 0.98. What is the ratio of the Rating (1=low 6=high) of Sub-Saharan Africa (all income levels) in 2008 to that in 2010?
Ensure brevity in your answer.  1.01. What is the ratio of the Rating (1=low 6=high) in Upper middle income in 2008 to that in 2010?
Make the answer very short. 0.99. What is the ratio of the Rating (1=low 6=high) in South Asia in 2008 to that in 2011?
Ensure brevity in your answer.  0.98. What is the ratio of the Rating (1=low 6=high) of Upper middle income in 2008 to that in 2011?
Make the answer very short. 0.94. What is the ratio of the Rating (1=low 6=high) of Kyrgyz Republic in 2008 to that in 2011?
Your answer should be compact. 1. What is the ratio of the Rating (1=low 6=high) in South Asia in 2008 to that in 2012?
Offer a very short reply. 0.98. What is the ratio of the Rating (1=low 6=high) in Sub-Saharan Africa (all income levels) in 2008 to that in 2012?
Offer a terse response. 1.01. What is the ratio of the Rating (1=low 6=high) in Upper middle income in 2008 to that in 2012?
Offer a very short reply. 0.96. What is the ratio of the Rating (1=low 6=high) of South Asia in 2008 to that in 2013?
Your answer should be compact. 0.98. What is the ratio of the Rating (1=low 6=high) of Sub-Saharan Africa (all income levels) in 2008 to that in 2013?
Your answer should be compact. 1.01. What is the ratio of the Rating (1=low 6=high) of Upper middle income in 2008 to that in 2013?
Offer a very short reply. 0.96. What is the ratio of the Rating (1=low 6=high) in South Asia in 2008 to that in 2014?
Offer a terse response. 1. What is the ratio of the Rating (1=low 6=high) of Kyrgyz Republic in 2008 to that in 2014?
Provide a short and direct response. 0.83. What is the ratio of the Rating (1=low 6=high) of South Asia in 2009 to that in 2010?
Your answer should be compact. 1.02. What is the ratio of the Rating (1=low 6=high) in South Asia in 2009 to that in 2011?
Offer a very short reply. 1.02. What is the ratio of the Rating (1=low 6=high) in Upper middle income in 2009 to that in 2011?
Ensure brevity in your answer.  0.96. What is the ratio of the Rating (1=low 6=high) of South Asia in 2009 to that in 2012?
Offer a very short reply. 1.02. What is the ratio of the Rating (1=low 6=high) in Sub-Saharan Africa (all income levels) in 2009 to that in 2012?
Your response must be concise. 1.01. What is the ratio of the Rating (1=low 6=high) of Upper middle income in 2009 to that in 2012?
Make the answer very short. 0.97. What is the ratio of the Rating (1=low 6=high) of South Asia in 2009 to that in 2013?
Offer a very short reply. 1.02. What is the ratio of the Rating (1=low 6=high) in Upper middle income in 2009 to that in 2013?
Make the answer very short. 0.97. What is the ratio of the Rating (1=low 6=high) in Kyrgyz Republic in 2009 to that in 2013?
Offer a terse response. 0.83. What is the ratio of the Rating (1=low 6=high) in South Asia in 2009 to that in 2014?
Your answer should be very brief. 1.05. What is the ratio of the Rating (1=low 6=high) of Sub-Saharan Africa (all income levels) in 2009 to that in 2014?
Ensure brevity in your answer.  1. What is the ratio of the Rating (1=low 6=high) in Upper middle income in 2009 to that in 2014?
Keep it short and to the point. 0.91. What is the ratio of the Rating (1=low 6=high) in Sub-Saharan Africa (all income levels) in 2010 to that in 2011?
Your answer should be compact. 0.98. What is the ratio of the Rating (1=low 6=high) of Upper middle income in 2010 to that in 2011?
Make the answer very short. 0.96. What is the ratio of the Rating (1=low 6=high) of Kyrgyz Republic in 2010 to that in 2011?
Your response must be concise. 1. What is the ratio of the Rating (1=low 6=high) in South Asia in 2010 to that in 2012?
Make the answer very short. 1. What is the ratio of the Rating (1=low 6=high) of Upper middle income in 2010 to that in 2012?
Offer a very short reply. 0.97. What is the ratio of the Rating (1=low 6=high) in Sub-Saharan Africa (all income levels) in 2010 to that in 2013?
Offer a terse response. 1. What is the ratio of the Rating (1=low 6=high) in Upper middle income in 2010 to that in 2013?
Your response must be concise. 0.97. What is the ratio of the Rating (1=low 6=high) in South Asia in 2010 to that in 2014?
Ensure brevity in your answer.  1.02. What is the ratio of the Rating (1=low 6=high) in Upper middle income in 2010 to that in 2014?
Keep it short and to the point. 0.91. What is the ratio of the Rating (1=low 6=high) in Kyrgyz Republic in 2010 to that in 2014?
Keep it short and to the point. 0.83. What is the ratio of the Rating (1=low 6=high) of Sub-Saharan Africa (all income levels) in 2011 to that in 2012?
Keep it short and to the point. 1.03. What is the ratio of the Rating (1=low 6=high) of Upper middle income in 2011 to that in 2012?
Offer a very short reply. 1.01. What is the ratio of the Rating (1=low 6=high) of Kyrgyz Republic in 2011 to that in 2012?
Make the answer very short. 0.83. What is the ratio of the Rating (1=low 6=high) of South Asia in 2011 to that in 2013?
Keep it short and to the point. 1. What is the ratio of the Rating (1=low 6=high) in Sub-Saharan Africa (all income levels) in 2011 to that in 2013?
Ensure brevity in your answer.  1.03. What is the ratio of the Rating (1=low 6=high) in Upper middle income in 2011 to that in 2013?
Keep it short and to the point. 1.01. What is the ratio of the Rating (1=low 6=high) of Kyrgyz Republic in 2011 to that in 2013?
Offer a terse response. 0.83. What is the ratio of the Rating (1=low 6=high) in South Asia in 2011 to that in 2014?
Give a very brief answer. 1.02. What is the ratio of the Rating (1=low 6=high) of Sub-Saharan Africa (all income levels) in 2011 to that in 2014?
Provide a short and direct response. 1.01. What is the ratio of the Rating (1=low 6=high) in Upper middle income in 2011 to that in 2014?
Keep it short and to the point. 0.95. What is the ratio of the Rating (1=low 6=high) in South Asia in 2012 to that in 2013?
Provide a succinct answer. 1. What is the ratio of the Rating (1=low 6=high) of Sub-Saharan Africa (all income levels) in 2012 to that in 2013?
Offer a very short reply. 1. What is the ratio of the Rating (1=low 6=high) of Upper middle income in 2012 to that in 2013?
Ensure brevity in your answer.  1. What is the ratio of the Rating (1=low 6=high) in Kyrgyz Republic in 2012 to that in 2013?
Make the answer very short. 1. What is the ratio of the Rating (1=low 6=high) in South Asia in 2012 to that in 2014?
Your answer should be compact. 1.02. What is the ratio of the Rating (1=low 6=high) in Sub-Saharan Africa (all income levels) in 2012 to that in 2014?
Give a very brief answer. 0.99. What is the ratio of the Rating (1=low 6=high) in Upper middle income in 2012 to that in 2014?
Offer a very short reply. 0.94. What is the ratio of the Rating (1=low 6=high) in South Asia in 2013 to that in 2014?
Your answer should be compact. 1.02. What is the ratio of the Rating (1=low 6=high) of Sub-Saharan Africa (all income levels) in 2013 to that in 2014?
Ensure brevity in your answer.  0.99. What is the ratio of the Rating (1=low 6=high) of Upper middle income in 2013 to that in 2014?
Offer a very short reply. 0.94. What is the ratio of the Rating (1=low 6=high) in Kyrgyz Republic in 2013 to that in 2014?
Provide a short and direct response. 1. What is the difference between the highest and the second highest Rating (1=low 6=high) in South Asia?
Ensure brevity in your answer.  0.06. What is the difference between the highest and the second highest Rating (1=low 6=high) in Sub-Saharan Africa (all income levels)?
Keep it short and to the point. 0.01. What is the difference between the highest and the second highest Rating (1=low 6=high) of Upper middle income?
Your response must be concise. 0.17. What is the difference between the highest and the lowest Rating (1=low 6=high) in South Asia?
Make the answer very short. 0.13. What is the difference between the highest and the lowest Rating (1=low 6=high) of Sub-Saharan Africa (all income levels)?
Your response must be concise. 0.07. What is the difference between the highest and the lowest Rating (1=low 6=high) of Upper middle income?
Ensure brevity in your answer.  0.47. 